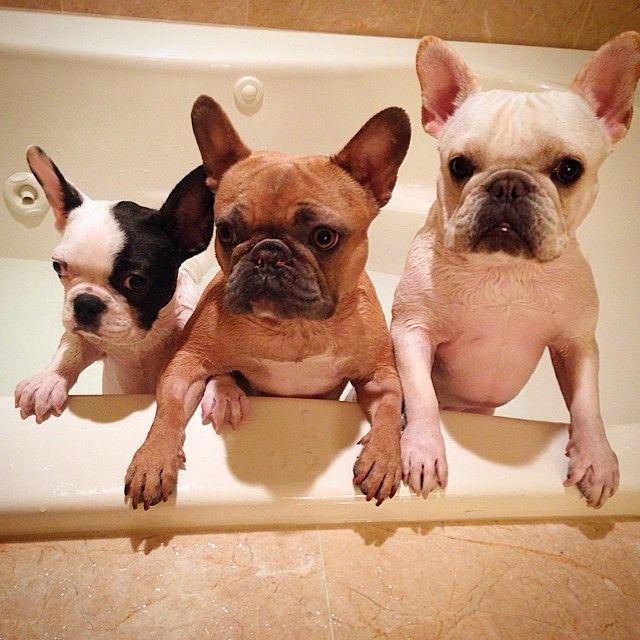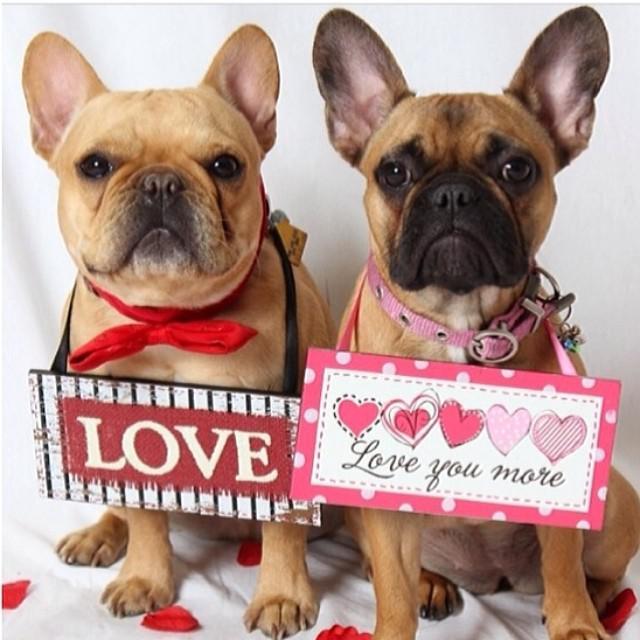The first image is the image on the left, the second image is the image on the right. Examine the images to the left and right. Is the description "In the left image, one white bulldog is alone in a white tub and has its front paws on the rim of the tub." accurate? Answer yes or no. No. 